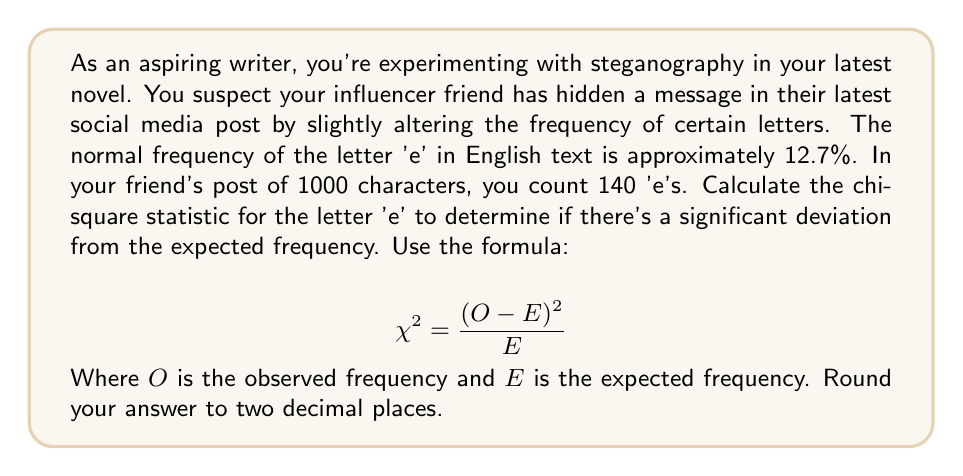What is the answer to this math problem? To solve this problem, we'll follow these steps:

1. Determine the expected frequency (E):
   The expected frequency of 'e' in a 1000-character text would be:
   $E = 1000 \times 0.127 = 127$ 'e's

2. We're given the observed frequency (O):
   $O = 140$ 'e's

3. Now, let's apply the chi-square formula:
   $$ \chi^2 = \frac{(O - E)^2}{E} $$
   
   $$ \chi^2 = \frac{(140 - 127)^2}{127} $$

4. Simplify:
   $$ \chi^2 = \frac{13^2}{127} = \frac{169}{127} $$

5. Calculate and round to two decimal places:
   $$ \chi^2 \approx 1.33 $$

This chi-square value indicates the degree of deviation from the expected frequency. A higher value suggests a more significant deviation, which could indicate a hidden message.
Answer: 1.33 